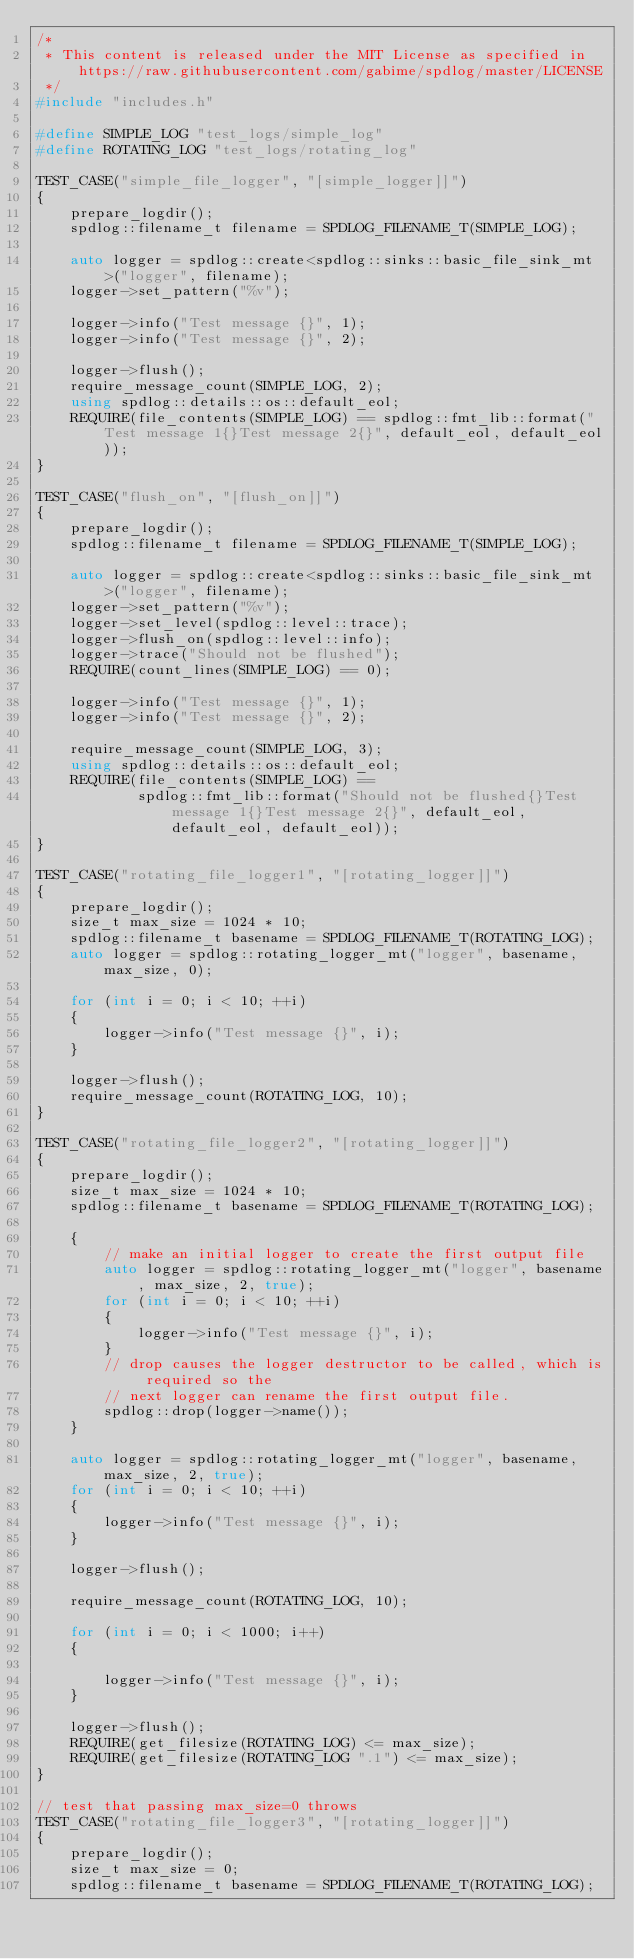Convert code to text. <code><loc_0><loc_0><loc_500><loc_500><_C++_>/*
 * This content is released under the MIT License as specified in https://raw.githubusercontent.com/gabime/spdlog/master/LICENSE
 */
#include "includes.h"

#define SIMPLE_LOG "test_logs/simple_log"
#define ROTATING_LOG "test_logs/rotating_log"

TEST_CASE("simple_file_logger", "[simple_logger]]")
{
    prepare_logdir();
    spdlog::filename_t filename = SPDLOG_FILENAME_T(SIMPLE_LOG);

    auto logger = spdlog::create<spdlog::sinks::basic_file_sink_mt>("logger", filename);
    logger->set_pattern("%v");

    logger->info("Test message {}", 1);
    logger->info("Test message {}", 2);

    logger->flush();
    require_message_count(SIMPLE_LOG, 2);
    using spdlog::details::os::default_eol;
    REQUIRE(file_contents(SIMPLE_LOG) == spdlog::fmt_lib::format("Test message 1{}Test message 2{}", default_eol, default_eol));
}

TEST_CASE("flush_on", "[flush_on]]")
{
    prepare_logdir();
    spdlog::filename_t filename = SPDLOG_FILENAME_T(SIMPLE_LOG);

    auto logger = spdlog::create<spdlog::sinks::basic_file_sink_mt>("logger", filename);
    logger->set_pattern("%v");
    logger->set_level(spdlog::level::trace);
    logger->flush_on(spdlog::level::info);
    logger->trace("Should not be flushed");
    REQUIRE(count_lines(SIMPLE_LOG) == 0);

    logger->info("Test message {}", 1);
    logger->info("Test message {}", 2);

    require_message_count(SIMPLE_LOG, 3);
    using spdlog::details::os::default_eol;
    REQUIRE(file_contents(SIMPLE_LOG) ==
            spdlog::fmt_lib::format("Should not be flushed{}Test message 1{}Test message 2{}", default_eol, default_eol, default_eol));
}

TEST_CASE("rotating_file_logger1", "[rotating_logger]]")
{
    prepare_logdir();
    size_t max_size = 1024 * 10;
    spdlog::filename_t basename = SPDLOG_FILENAME_T(ROTATING_LOG);
    auto logger = spdlog::rotating_logger_mt("logger", basename, max_size, 0);

    for (int i = 0; i < 10; ++i)
    {
        logger->info("Test message {}", i);
    }

    logger->flush();
    require_message_count(ROTATING_LOG, 10);
}

TEST_CASE("rotating_file_logger2", "[rotating_logger]]")
{
    prepare_logdir();
    size_t max_size = 1024 * 10;
    spdlog::filename_t basename = SPDLOG_FILENAME_T(ROTATING_LOG);

    {
        // make an initial logger to create the first output file
        auto logger = spdlog::rotating_logger_mt("logger", basename, max_size, 2, true);
        for (int i = 0; i < 10; ++i)
        {
            logger->info("Test message {}", i);
        }
        // drop causes the logger destructor to be called, which is required so the
        // next logger can rename the first output file.
        spdlog::drop(logger->name());
    }

    auto logger = spdlog::rotating_logger_mt("logger", basename, max_size, 2, true);
    for (int i = 0; i < 10; ++i)
    {
        logger->info("Test message {}", i);
    }

    logger->flush();

    require_message_count(ROTATING_LOG, 10);

    for (int i = 0; i < 1000; i++)
    {

        logger->info("Test message {}", i);
    }

    logger->flush();
    REQUIRE(get_filesize(ROTATING_LOG) <= max_size);
    REQUIRE(get_filesize(ROTATING_LOG ".1") <= max_size);
}

// test that passing max_size=0 throws
TEST_CASE("rotating_file_logger3", "[rotating_logger]]")
{
    prepare_logdir();
    size_t max_size = 0;
    spdlog::filename_t basename = SPDLOG_FILENAME_T(ROTATING_LOG);</code> 